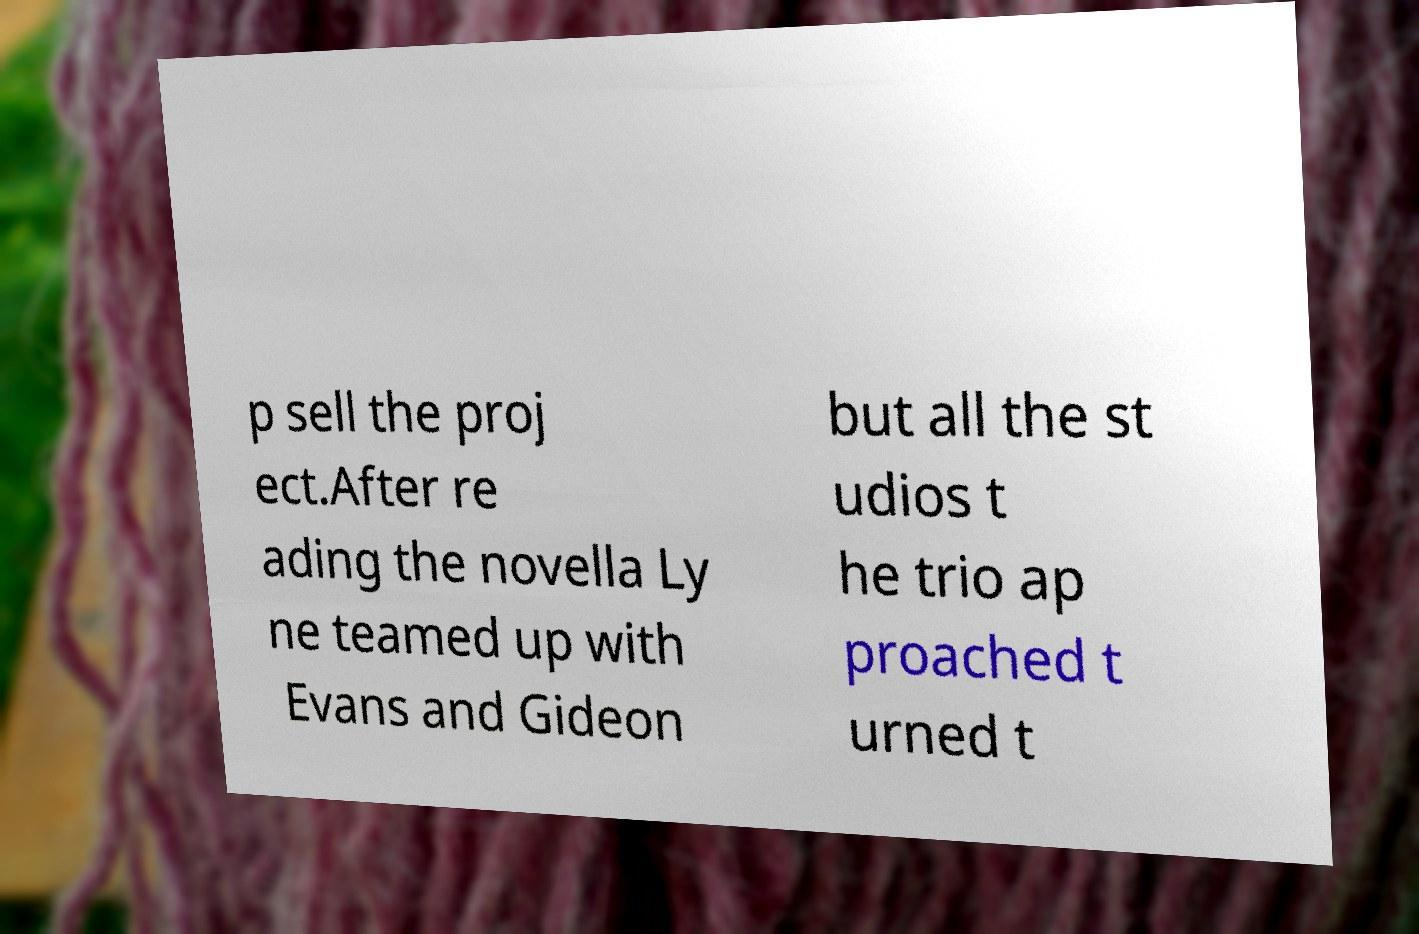Could you extract and type out the text from this image? p sell the proj ect.After re ading the novella Ly ne teamed up with Evans and Gideon but all the st udios t he trio ap proached t urned t 